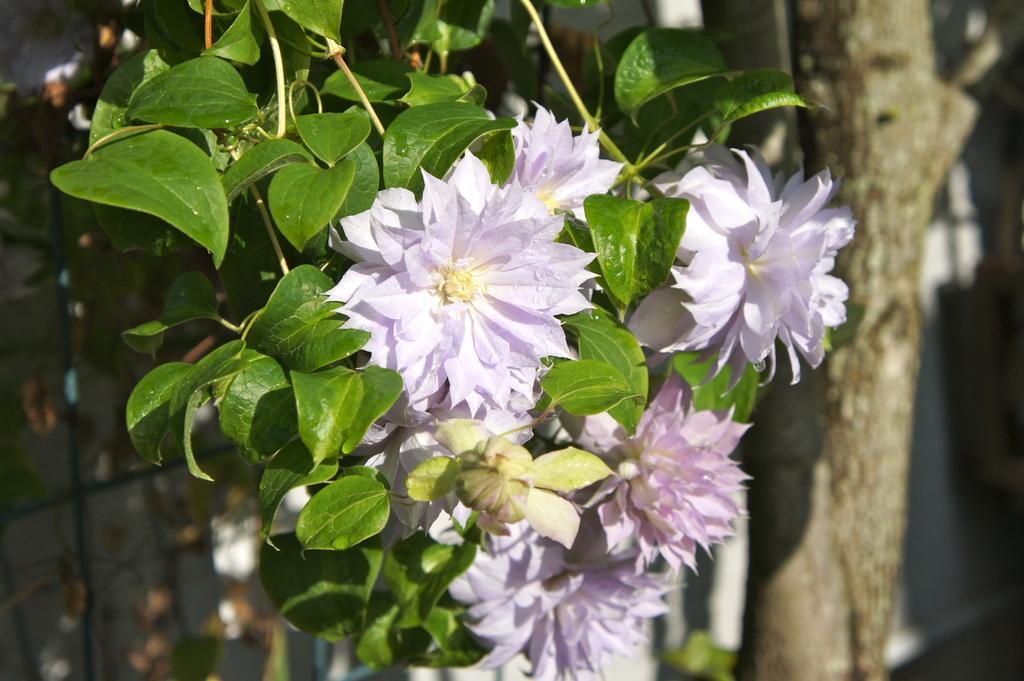Could you give a brief overview of what you see in this image? In the center of the image there are flowers and leaves. To the right side of the image there is a tree trunk. 